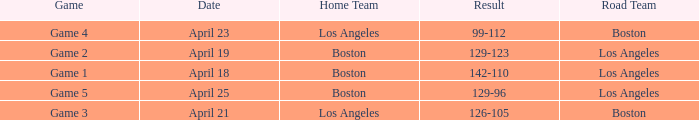WHAT IS THE RESULT WITH THE BOSTON ROAD TEAM, ON APRIL 23? 99-112. Could you parse the entire table? {'header': ['Game', 'Date', 'Home Team', 'Result', 'Road Team'], 'rows': [['Game 4', 'April 23', 'Los Angeles', '99-112', 'Boston'], ['Game 2', 'April 19', 'Boston', '129-123', 'Los Angeles'], ['Game 1', 'April 18', 'Boston', '142-110', 'Los Angeles'], ['Game 5', 'April 25', 'Boston', '129-96', 'Los Angeles'], ['Game 3', 'April 21', 'Los Angeles', '126-105', 'Boston']]} 